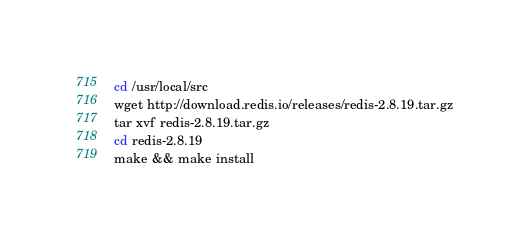<code> <loc_0><loc_0><loc_500><loc_500><_Bash_>cd /usr/local/src
wget http://download.redis.io/releases/redis-2.8.19.tar.gz
tar xvf redis-2.8.19.tar.gz
cd redis-2.8.19
make && make install
</code> 